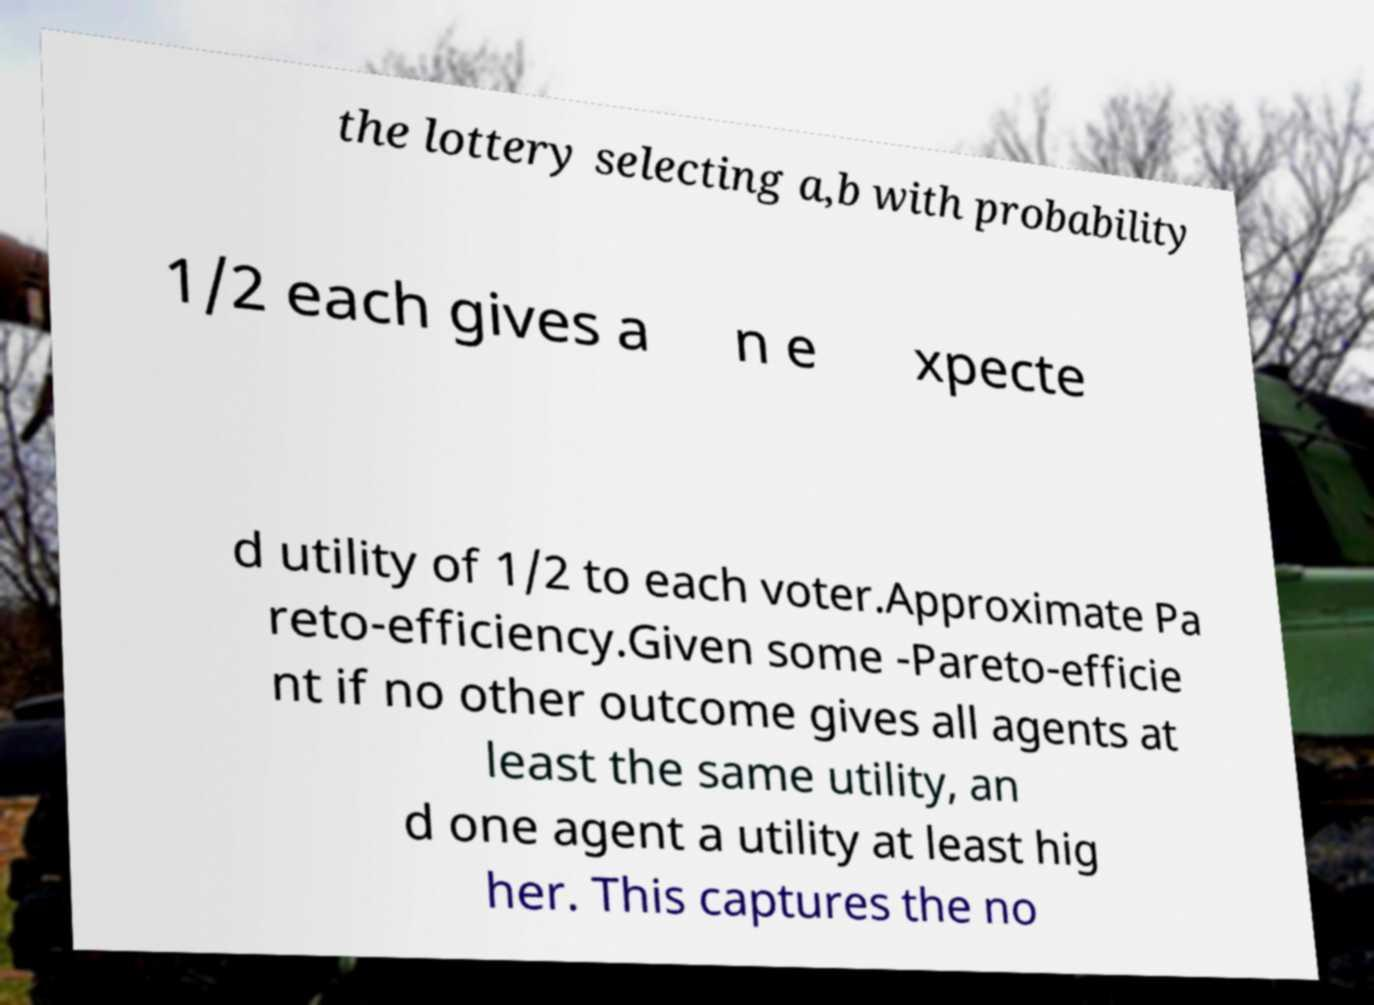What messages or text are displayed in this image? I need them in a readable, typed format. the lottery selecting a,b with probability 1/2 each gives a n e xpecte d utility of 1/2 to each voter.Approximate Pa reto-efficiency.Given some -Pareto-efficie nt if no other outcome gives all agents at least the same utility, an d one agent a utility at least hig her. This captures the no 